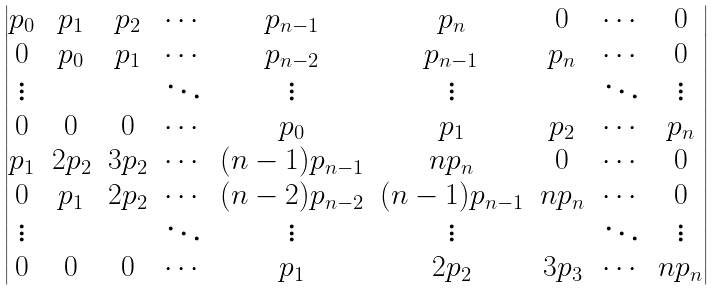<formula> <loc_0><loc_0><loc_500><loc_500>\begin{vmatrix} p _ { 0 } & p _ { 1 } & p _ { 2 } & \cdots & p _ { n - 1 } & p _ { n } & 0 & \cdots & 0 \\ 0 & p _ { 0 } & p _ { 1 } & \cdots & p _ { n - 2 } & p _ { n - 1 } & p _ { n } & \cdots & 0 \\ \vdots & & & \ddots & \vdots & \vdots & & \ddots & \vdots \\ 0 & 0 & 0 & \cdots & p _ { 0 } & p _ { 1 } & p _ { 2 } & \cdots & p _ { n } \\ p _ { 1 } & 2 p _ { 2 } & 3 p _ { 2 } & \cdots & ( n - 1 ) p _ { n - 1 } & n p _ { n } & 0 & \cdots & 0 \\ 0 & p _ { 1 } & 2 p _ { 2 } & \cdots & ( n - 2 ) p _ { n - 2 } & ( n - 1 ) p _ { n - 1 } & n p _ { n } & \cdots & 0 \\ \vdots & & & \ddots & \vdots & \vdots & & \ddots & \vdots \\ 0 & 0 & 0 & \cdots & p _ { 1 } & 2 p _ { 2 } & 3 p _ { 3 } & \cdots & n p _ { n } \\ \end{vmatrix}</formula> 